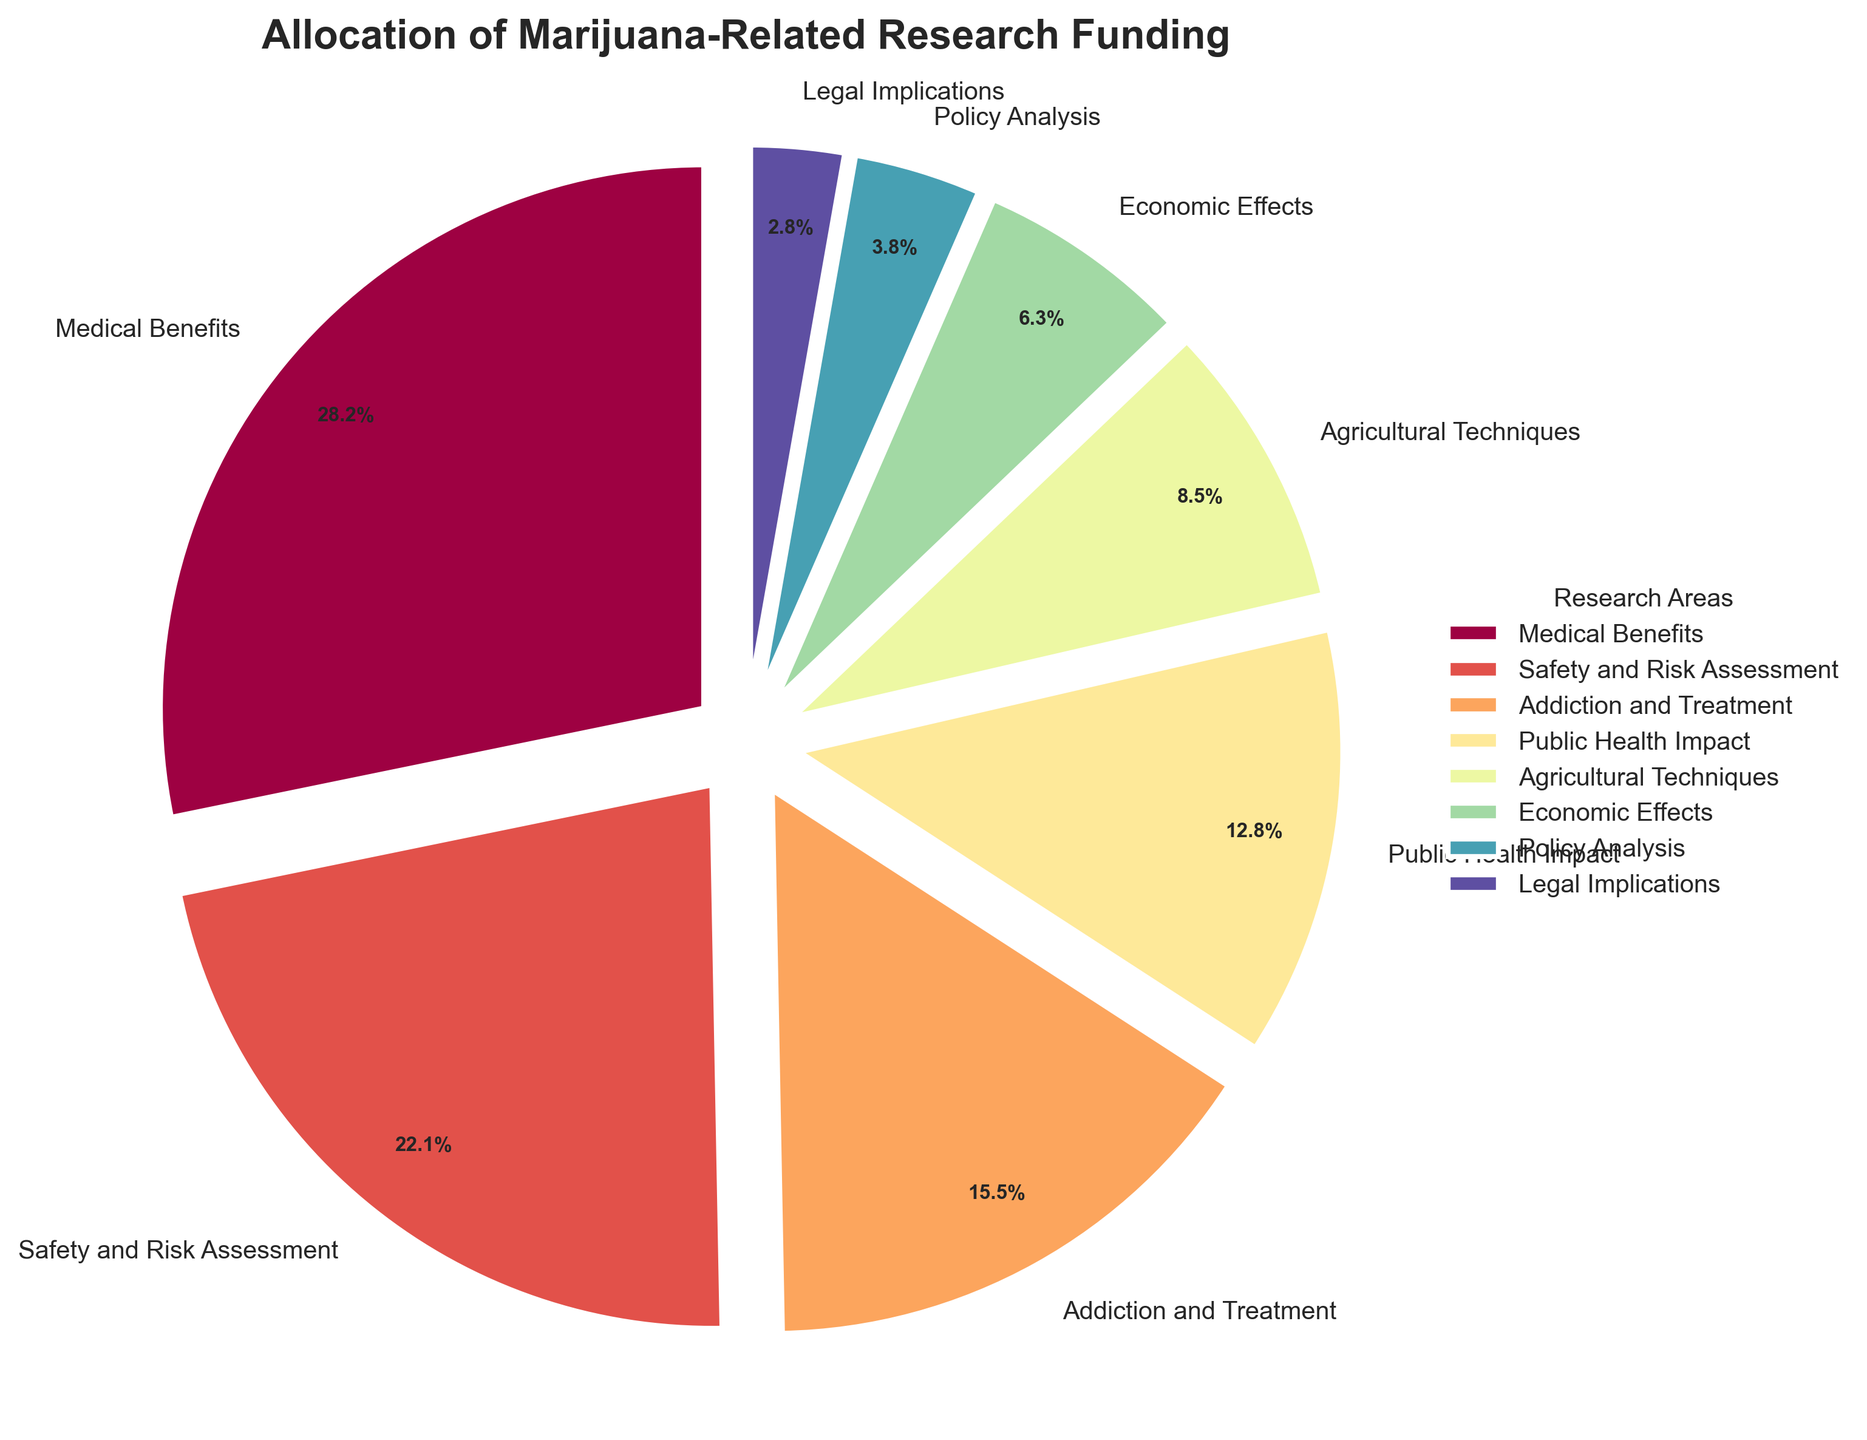Which research area receives the highest percentage of funding? The figure shows the different funding percentages, and the slice corresponding to "Medical Benefits" is the largest. Thus, "Medical Benefits" receives the highest percentage of funding.
Answer: Medical Benefits How much more funding does "Medical Benefits" receive compared to "Addiction and Treatment"? Look at the slices for "Medical Benefits" and "Addiction and Treatment". "Medical Benefits" has a funding percentage of 28.5%, and "Addiction and Treatment" has 15.7%. The difference is 28.5% - 15.7% = 12.8%.
Answer: 12.8% Which two research areas have the closest funding percentages? Compare the funding percentages: "Agricultural Techniques" (8.6%) and "Economic Effects" (6.4%) are relatively close to each other compared to other pairs.
Answer: Agricultural Techniques and Economic Effects What is the combined funding percentage for "Public Health Impact" and "Safety and Risk Assessment"? Add the percentages for "Public Health Impact" (12.9%) and "Safety and Risk Assessment" (22.3%). The combined funding is 12.9% + 22.3% = 35.2%.
Answer: 35.2% Which research area has the second smallest percentage of funding? Examine the slices to identify the smallest and the next smallest. "Legal Implications" is the smallest (2.8%), and "Policy Analysis" is the next smallest (3.8%).
Answer: Policy Analysis What is the total percentage of funding allocated to areas related to risk and safety (i.e., "Safety and Risk Assessment" and "Addiction and Treatment")? Add the percentages for "Safety and Risk Assessment" (22.3%) and "Addiction and Treatment" (15.7%). The total is 22.3% + 15.7% = 38.0%.
Answer: 38.0% Which areas individually receive less than 5% of the total funding? Identify slices with less than 5% funding: "Legal Implications" (2.8%) and "Policy Analysis" (3.8%).
Answer: Legal Implications and Policy Analysis How does the funding for "Economic Effects" compare to the total funding for both "Medical Benefits" and "Public Health Impact"? "Medical Benefits" has 28.5%, and "Public Health Impact" has 12.9%. Their combined total is 28.5% + 12.9% = 41.4%. "Economic Effects" has 6.4%. Thus, "Economic Effects" is much less than the combined amount of 41.4%.
Answer: Much less 